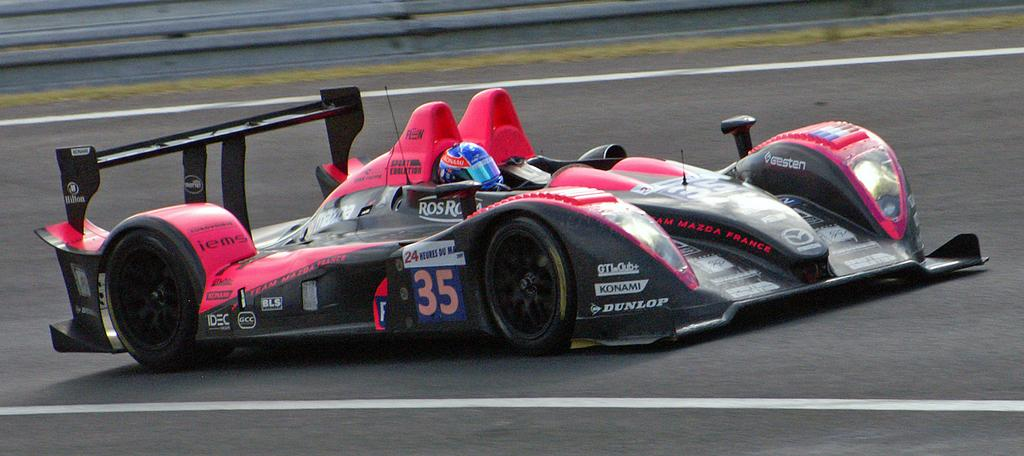What is the person in the image doing? There is a person driving a car in the image. Where is the car located? The car is on the road. What safety feature can be seen at the top of the image? There is a road safety barrier at the top of the image. What markings are visible on the road? There are road safety markings on the road. Can you see a rabbit reading a book in the car? There is no rabbit or book present in the image; it only shows a person driving a car on the road. 